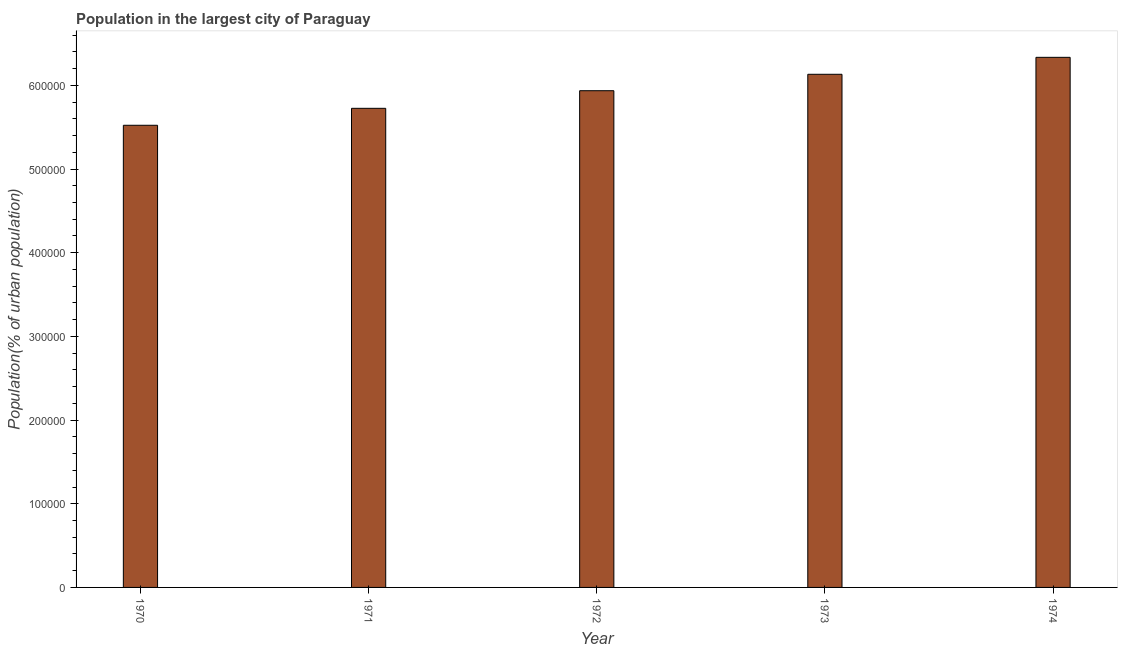Does the graph contain any zero values?
Offer a terse response. No. What is the title of the graph?
Ensure brevity in your answer.  Population in the largest city of Paraguay. What is the label or title of the Y-axis?
Ensure brevity in your answer.  Population(% of urban population). What is the population in largest city in 1974?
Make the answer very short. 6.33e+05. Across all years, what is the maximum population in largest city?
Provide a succinct answer. 6.33e+05. Across all years, what is the minimum population in largest city?
Offer a very short reply. 5.52e+05. In which year was the population in largest city maximum?
Keep it short and to the point. 1974. What is the sum of the population in largest city?
Give a very brief answer. 2.97e+06. What is the difference between the population in largest city in 1970 and 1973?
Make the answer very short. -6.09e+04. What is the average population in largest city per year?
Provide a succinct answer. 5.93e+05. What is the median population in largest city?
Keep it short and to the point. 5.94e+05. In how many years, is the population in largest city greater than 40000 %?
Your response must be concise. 5. Do a majority of the years between 1972 and 1971 (inclusive) have population in largest city greater than 360000 %?
Give a very brief answer. No. What is the ratio of the population in largest city in 1971 to that in 1974?
Give a very brief answer. 0.9. Is the difference between the population in largest city in 1971 and 1973 greater than the difference between any two years?
Provide a succinct answer. No. What is the difference between the highest and the second highest population in largest city?
Ensure brevity in your answer.  2.03e+04. Is the sum of the population in largest city in 1972 and 1973 greater than the maximum population in largest city across all years?
Offer a terse response. Yes. What is the difference between the highest and the lowest population in largest city?
Your answer should be compact. 8.12e+04. How many bars are there?
Offer a very short reply. 5. How many years are there in the graph?
Your answer should be compact. 5. What is the difference between two consecutive major ticks on the Y-axis?
Offer a very short reply. 1.00e+05. What is the Population(% of urban population) in 1970?
Your answer should be very brief. 5.52e+05. What is the Population(% of urban population) of 1971?
Your answer should be compact. 5.73e+05. What is the Population(% of urban population) in 1972?
Offer a terse response. 5.94e+05. What is the Population(% of urban population) of 1973?
Keep it short and to the point. 6.13e+05. What is the Population(% of urban population) in 1974?
Offer a terse response. 6.33e+05. What is the difference between the Population(% of urban population) in 1970 and 1971?
Provide a short and direct response. -2.03e+04. What is the difference between the Population(% of urban population) in 1970 and 1972?
Offer a very short reply. -4.13e+04. What is the difference between the Population(% of urban population) in 1970 and 1973?
Provide a short and direct response. -6.09e+04. What is the difference between the Population(% of urban population) in 1970 and 1974?
Your answer should be compact. -8.12e+04. What is the difference between the Population(% of urban population) in 1971 and 1972?
Provide a short and direct response. -2.10e+04. What is the difference between the Population(% of urban population) in 1971 and 1973?
Your response must be concise. -4.07e+04. What is the difference between the Population(% of urban population) in 1971 and 1974?
Give a very brief answer. -6.09e+04. What is the difference between the Population(% of urban population) in 1972 and 1973?
Ensure brevity in your answer.  -1.96e+04. What is the difference between the Population(% of urban population) in 1972 and 1974?
Your answer should be very brief. -3.99e+04. What is the difference between the Population(% of urban population) in 1973 and 1974?
Ensure brevity in your answer.  -2.03e+04. What is the ratio of the Population(% of urban population) in 1970 to that in 1971?
Offer a very short reply. 0.96. What is the ratio of the Population(% of urban population) in 1970 to that in 1973?
Offer a very short reply. 0.9. What is the ratio of the Population(% of urban population) in 1970 to that in 1974?
Keep it short and to the point. 0.87. What is the ratio of the Population(% of urban population) in 1971 to that in 1972?
Your response must be concise. 0.96. What is the ratio of the Population(% of urban population) in 1971 to that in 1973?
Your answer should be compact. 0.93. What is the ratio of the Population(% of urban population) in 1971 to that in 1974?
Your answer should be very brief. 0.9. What is the ratio of the Population(% of urban population) in 1972 to that in 1974?
Your answer should be very brief. 0.94. What is the ratio of the Population(% of urban population) in 1973 to that in 1974?
Make the answer very short. 0.97. 